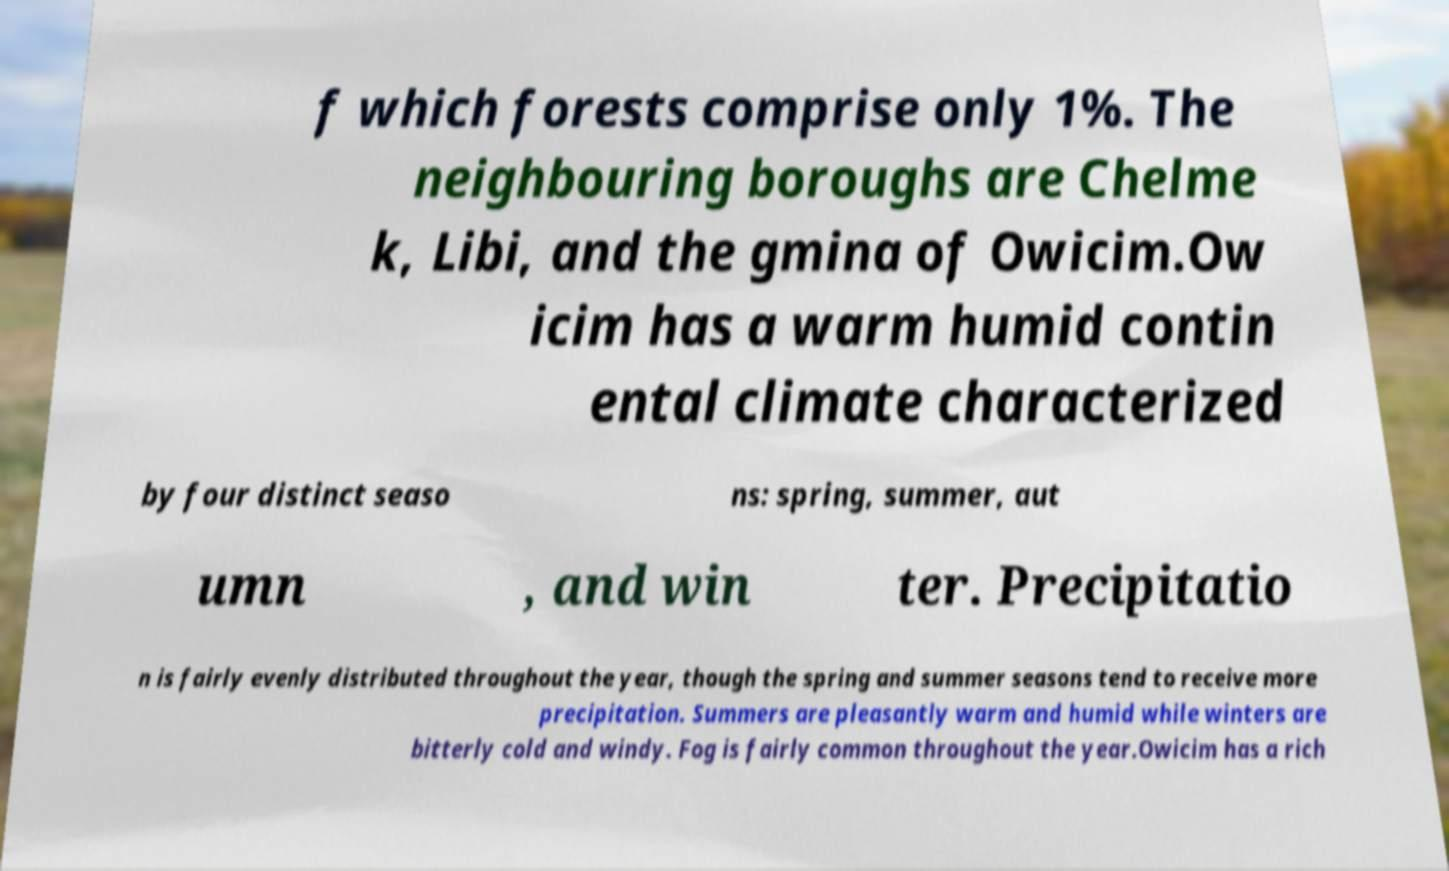Please read and relay the text visible in this image. What does it say? f which forests comprise only 1%. The neighbouring boroughs are Chelme k, Libi, and the gmina of Owicim.Ow icim has a warm humid contin ental climate characterized by four distinct seaso ns: spring, summer, aut umn , and win ter. Precipitatio n is fairly evenly distributed throughout the year, though the spring and summer seasons tend to receive more precipitation. Summers are pleasantly warm and humid while winters are bitterly cold and windy. Fog is fairly common throughout the year.Owicim has a rich 